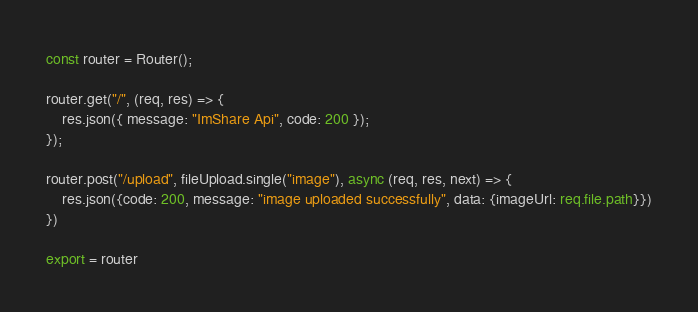Convert code to text. <code><loc_0><loc_0><loc_500><loc_500><_TypeScript_>const router = Router();

router.get("/", (req, res) => {
	res.json({ message: "ImShare Api", code: 200 });
});

router.post("/upload", fileUpload.single("image"), async (req, res, next) => {
	res.json({code: 200, message: "image uploaded successfully", data: {imageUrl: req.file.path}})
})

export = router
</code> 